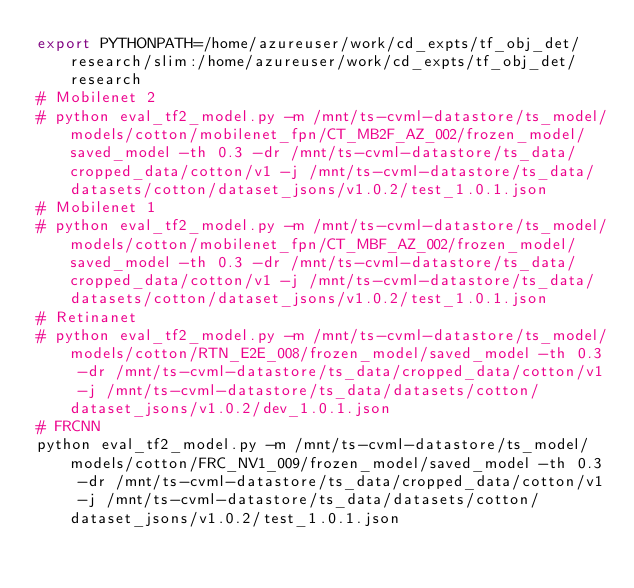Convert code to text. <code><loc_0><loc_0><loc_500><loc_500><_Bash_>export PYTHONPATH=/home/azureuser/work/cd_expts/tf_obj_det/research/slim:/home/azureuser/work/cd_expts/tf_obj_det/research
# Mobilenet 2
# python eval_tf2_model.py -m /mnt/ts-cvml-datastore/ts_model/models/cotton/mobilenet_fpn/CT_MB2F_AZ_002/frozen_model/saved_model -th 0.3 -dr /mnt/ts-cvml-datastore/ts_data/cropped_data/cotton/v1 -j /mnt/ts-cvml-datastore/ts_data/datasets/cotton/dataset_jsons/v1.0.2/test_1.0.1.json
# Mobilenet 1
# python eval_tf2_model.py -m /mnt/ts-cvml-datastore/ts_model/models/cotton/mobilenet_fpn/CT_MBF_AZ_002/frozen_model/saved_model -th 0.3 -dr /mnt/ts-cvml-datastore/ts_data/cropped_data/cotton/v1 -j /mnt/ts-cvml-datastore/ts_data/datasets/cotton/dataset_jsons/v1.0.2/test_1.0.1.json
# Retinanet
# python eval_tf2_model.py -m /mnt/ts-cvml-datastore/ts_model/models/cotton/RTN_E2E_008/frozen_model/saved_model -th 0.3 -dr /mnt/ts-cvml-datastore/ts_data/cropped_data/cotton/v1 -j /mnt/ts-cvml-datastore/ts_data/datasets/cotton/dataset_jsons/v1.0.2/dev_1.0.1.json
# FRCNN
python eval_tf2_model.py -m /mnt/ts-cvml-datastore/ts_model/models/cotton/FRC_NV1_009/frozen_model/saved_model -th 0.3 -dr /mnt/ts-cvml-datastore/ts_data/cropped_data/cotton/v1 -j /mnt/ts-cvml-datastore/ts_data/datasets/cotton/dataset_jsons/v1.0.2/test_1.0.1.json
</code> 